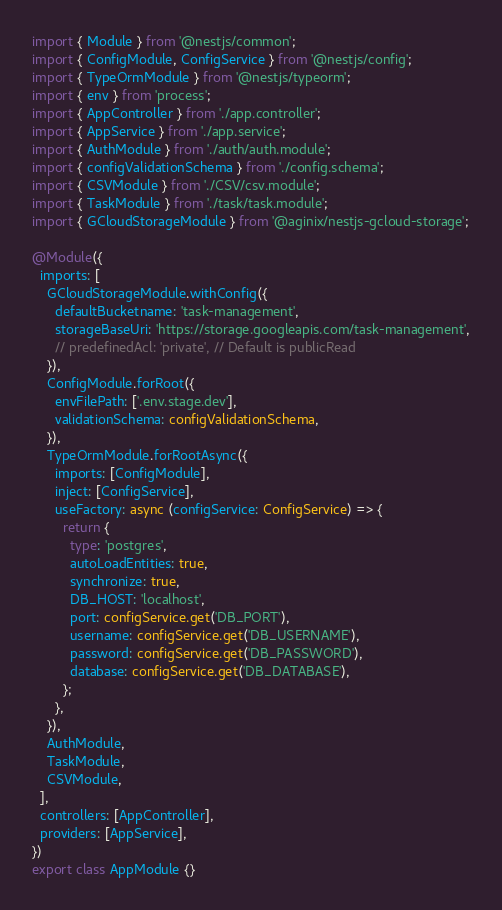<code> <loc_0><loc_0><loc_500><loc_500><_TypeScript_>import { Module } from '@nestjs/common';
import { ConfigModule, ConfigService } from '@nestjs/config';
import { TypeOrmModule } from '@nestjs/typeorm';
import { env } from 'process';
import { AppController } from './app.controller';
import { AppService } from './app.service';
import { AuthModule } from './auth/auth.module';
import { configValidationSchema } from './config.schema';
import { CSVModule } from './CSV/csv.module';
import { TaskModule } from './task/task.module';
import { GCloudStorageModule } from '@aginix/nestjs-gcloud-storage';

@Module({
  imports: [
    GCloudStorageModule.withConfig({
      defaultBucketname: 'task-management',
      storageBaseUri: 'https://storage.googleapis.com/task-management',
      // predefinedAcl: 'private', // Default is publicRead
    }),
    ConfigModule.forRoot({
      envFilePath: ['.env.stage.dev'],
      validationSchema: configValidationSchema,
    }),
    TypeOrmModule.forRootAsync({
      imports: [ConfigModule],
      inject: [ConfigService],
      useFactory: async (configService: ConfigService) => {
        return {
          type: 'postgres',
          autoLoadEntities: true,
          synchronize: true,
          DB_HOST: 'localhost',
          port: configService.get('DB_PORT'),
          username: configService.get('DB_USERNAME'),
          password: configService.get('DB_PASSWORD'),
          database: configService.get('DB_DATABASE'),
        };
      },
    }),
    AuthModule,
    TaskModule,
    CSVModule,
  ],
  controllers: [AppController],
  providers: [AppService],
})
export class AppModule {}
</code> 